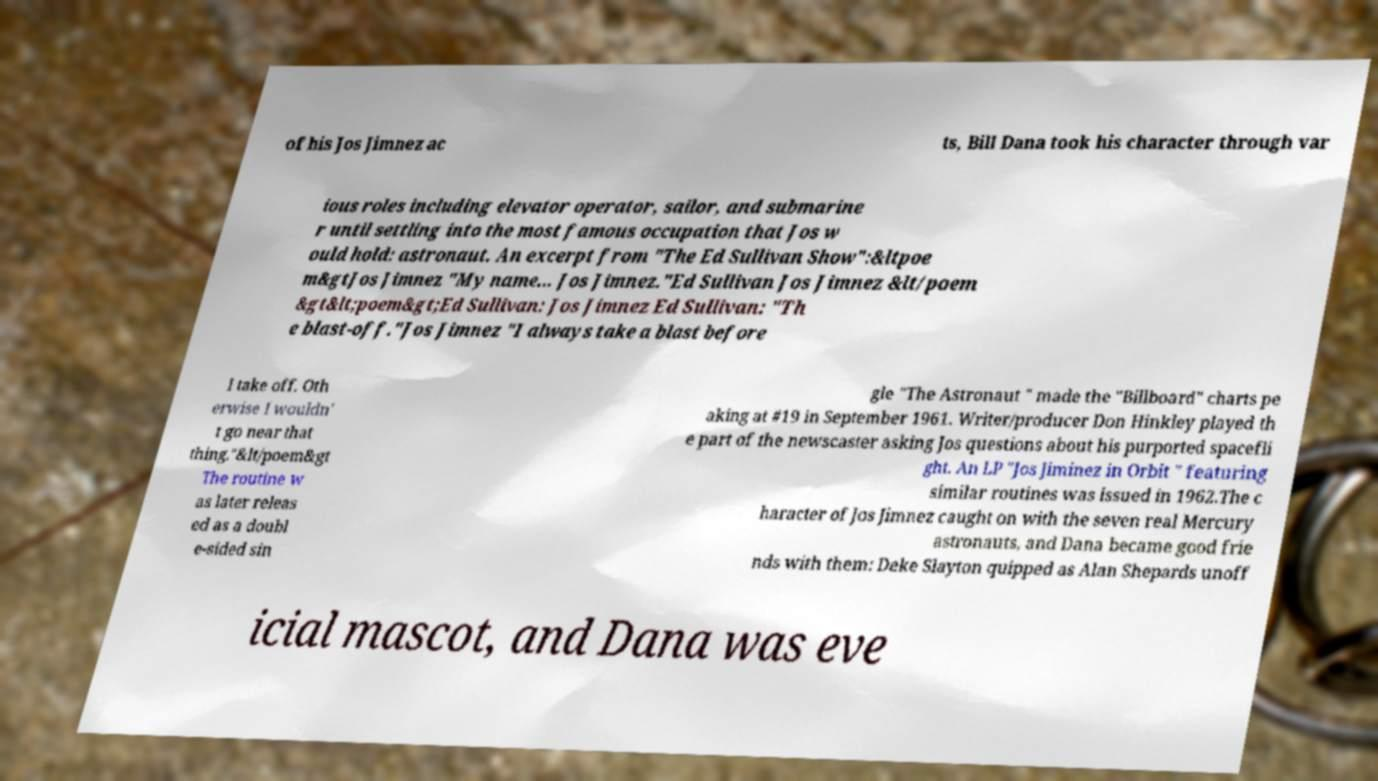Please identify and transcribe the text found in this image. of his Jos Jimnez ac ts, Bill Dana took his character through var ious roles including elevator operator, sailor, and submarine r until settling into the most famous occupation that Jos w ould hold: astronaut. An excerpt from "The Ed Sullivan Show":&ltpoe m&gtJos Jimnez "My name... Jos Jimnez."Ed Sullivan Jos Jimnez &lt/poem &gt&lt;poem&gt;Ed Sullivan: Jos Jimnez Ed Sullivan: "Th e blast-off."Jos Jimnez "I always take a blast before I take off. Oth erwise I wouldn' t go near that thing."&lt/poem&gt The routine w as later releas ed as a doubl e-sided sin gle "The Astronaut " made the "Billboard" charts pe aking at #19 in September 1961. Writer/producer Don Hinkley played th e part of the newscaster asking Jos questions about his purported spacefli ght. An LP "Jos Jiminez in Orbit " featuring similar routines was issued in 1962.The c haracter of Jos Jimnez caught on with the seven real Mercury astronauts, and Dana became good frie nds with them: Deke Slayton quipped as Alan Shepards unoff icial mascot, and Dana was eve 